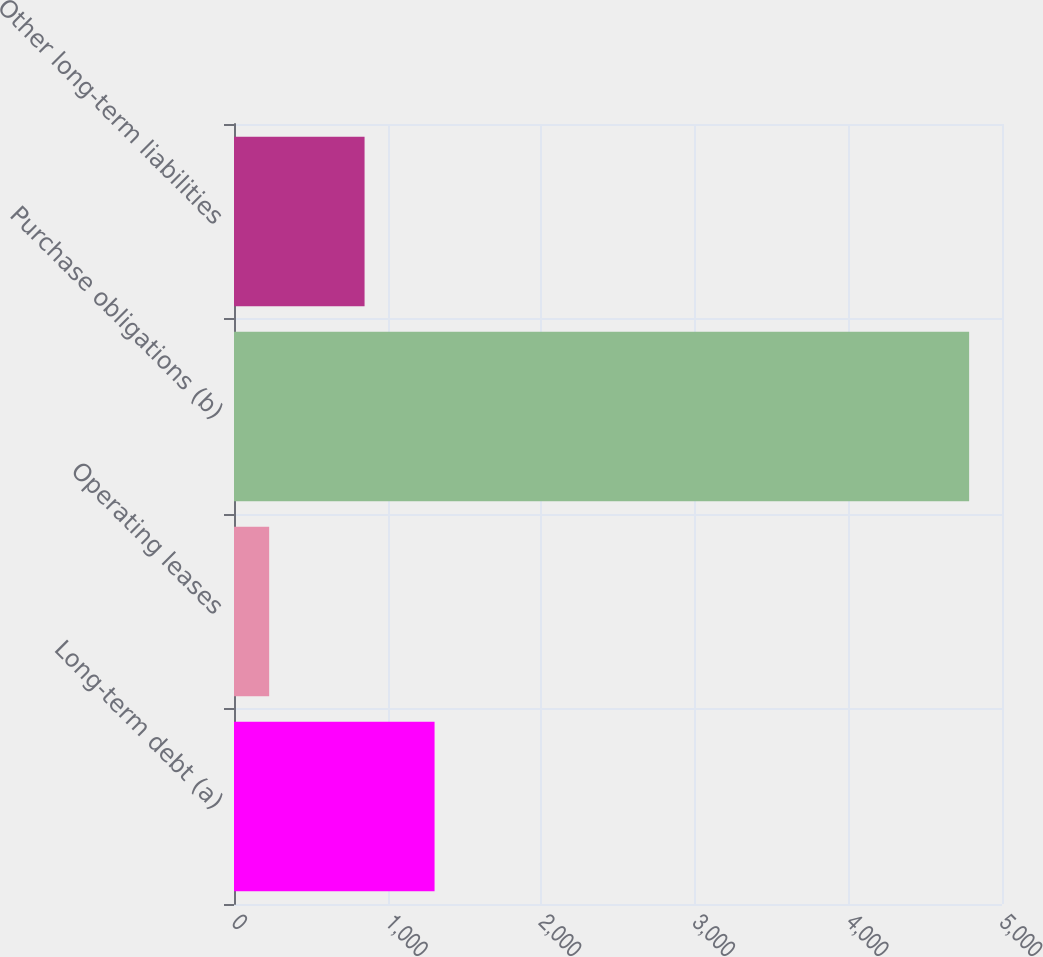Convert chart to OTSL. <chart><loc_0><loc_0><loc_500><loc_500><bar_chart><fcel>Long-term debt (a)<fcel>Operating leases<fcel>Purchase obligations (b)<fcel>Other long-term liabilities<nl><fcel>1305.7<fcel>229<fcel>4786<fcel>850<nl></chart> 